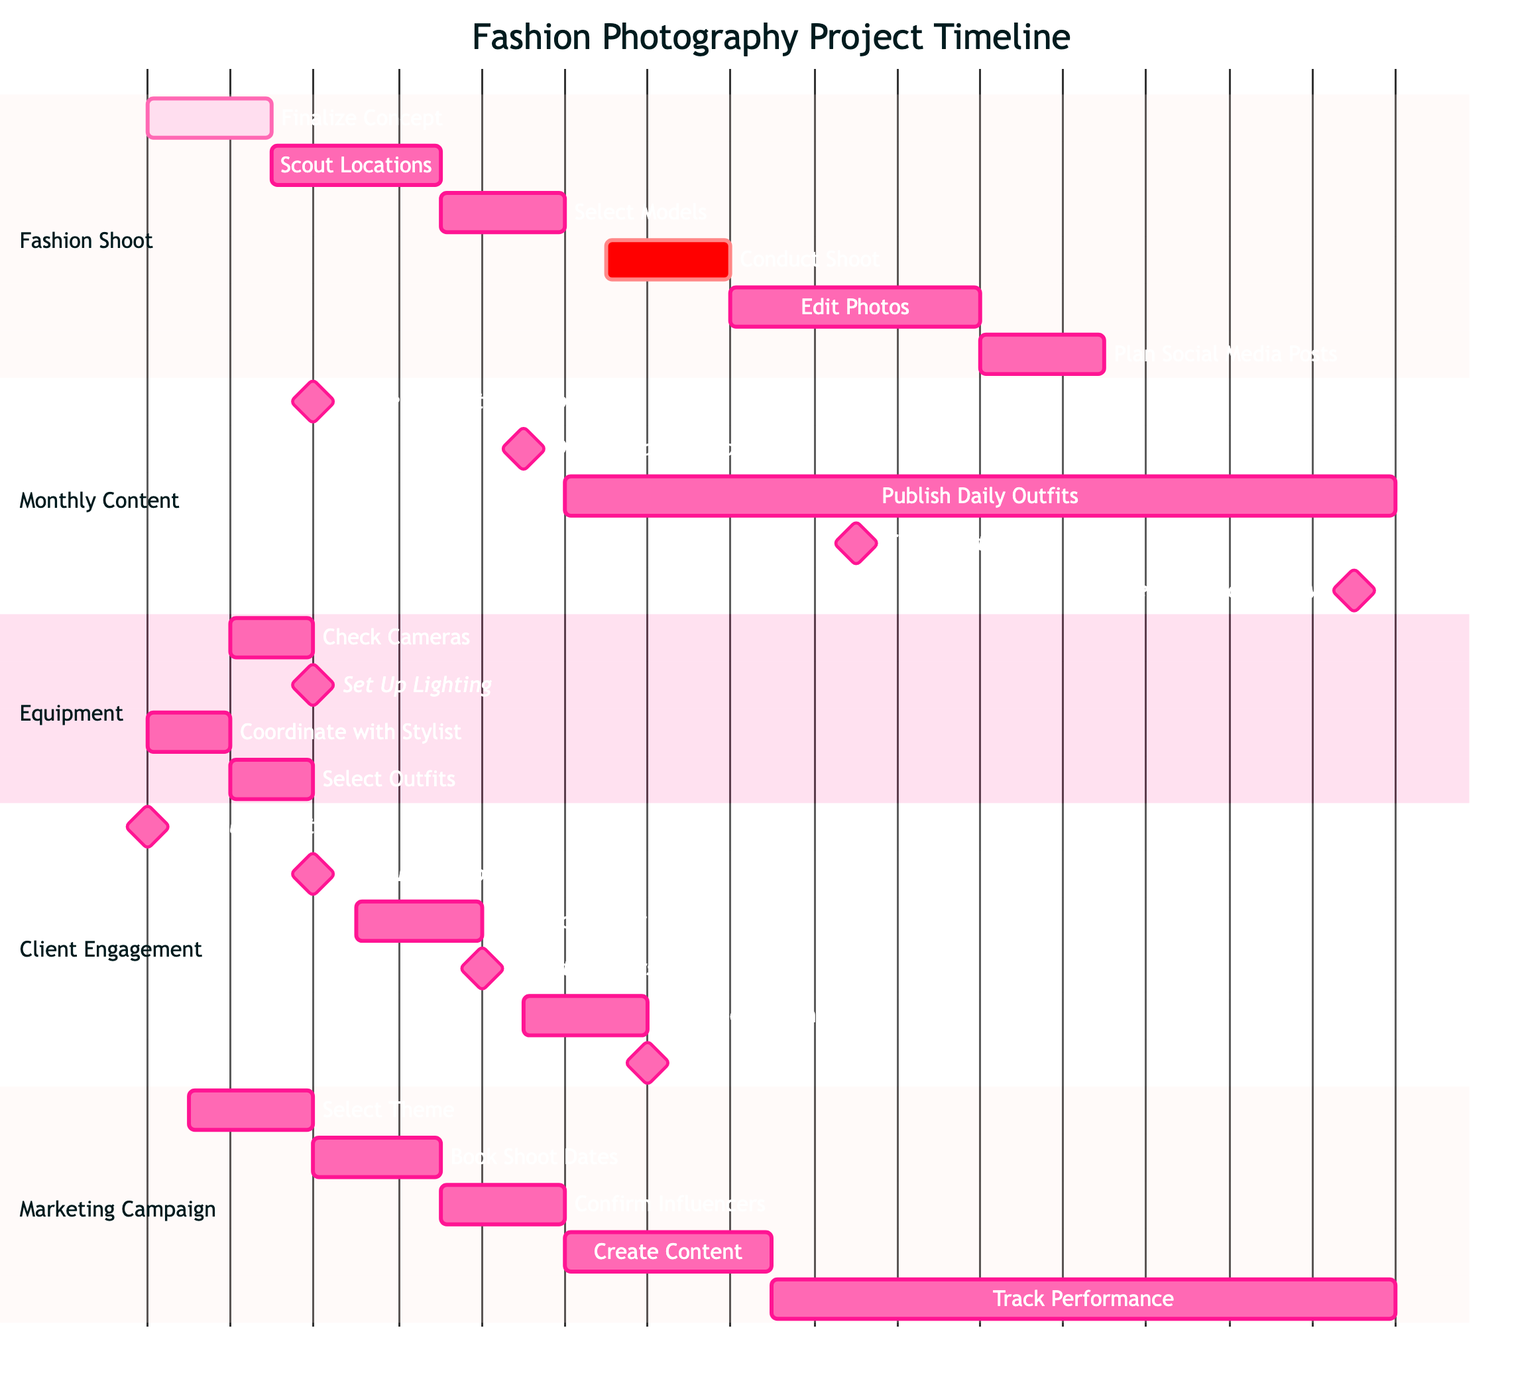What is the duration of the "Conduct Shoot" task? The "Conduct Shoot" task starts on November 12, 2023, and ends on November 14, 2023. This gives a total duration of 3 days (from Nov 12 to Nov 14 inclusive).
Answer: 3 days When does the "Publish Daily Outfits" activity start? The "Publish Daily Outfits" activity begins on November 11, 2023, according to the timeline in the Monthly Content section.
Answer: November 11 How many milestones are there in the "Client Engagement and Delivery Schedule"? In the "Client Engagement and Delivery Schedule" section, there are four milestones indicated: Initial Consultation, Conduct Photoshoot, Client Reviews, and Final Delivery.
Answer: 4 What is the start date for "Monitoring and Analyzing Results"? The "Monitoring and Analyzing Results" task starts on November 16, 2023, as shown in the Marketing Campaign Planning section of the diagram.
Answer: November 16 Which task overlaps with "Select Models"? The task "Scout Locations" overlaps with "Select Models" because "Scout Locations" ends on November 7 and "Select Models" starts on November 8.
Answer: Scout Locations What is the last task in the "Fashion Shoot" section? The last task in the "Fashion Shoot" section is "Plan Social Media Posts," which ends on November 23, 2023.
Answer: Plan Social Media Posts What is the total number of tasks listed in the "Equipment and Resource Allocation"? In the "Equipment and Resource Allocation" section, there are four tasks listed: Check Cameras, Set Up Lighting, Coordinate with Stylist, and Select Outfits. The total number of tasks is four.
Answer: 4 Which task is labeled as "crit" in the diagram? The task labeled as "crit" is "Conduct Shoot," indicating its critical nature in the project timeline.
Answer: Conduct Shoot How many days are allocated for "Edit and Review"? The "Edit and Review" phase runs from November 6 to November 8, 2023, giving a total of 3 days (from Nov 6 to Nov 8 inclusive).
Answer: 3 days 